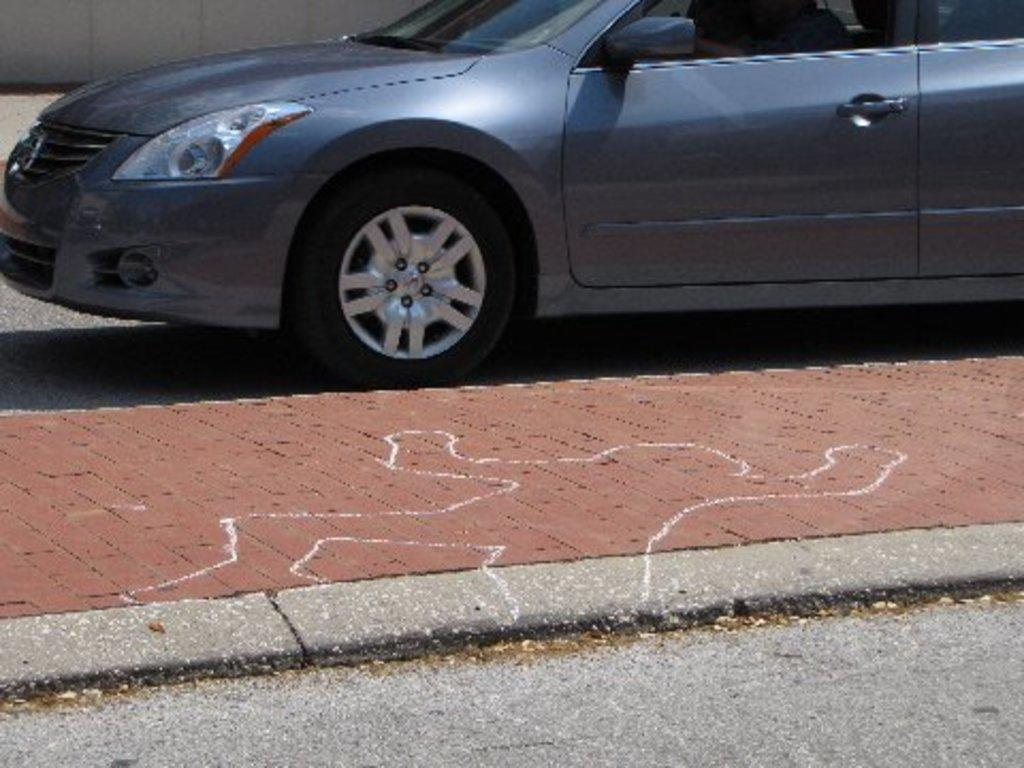What can be seen on the road in the image? There is a car on the road in the image. What is present at the bottom of the image? There is a pavement with some painting on it at the bottom of the image. What is located at the left top of the image? There is a wall at the left top of the image. What type of surface is visible at the bottom of the image? There is a road visible at the bottom of the image. What type of wax can be seen melting on the car in the image? There is no wax present in the image, and the car is not melting. What town is visible in the background of the image? There is no town visible in the image; it only shows a car, a wall, a road, and a pavement with painting. 